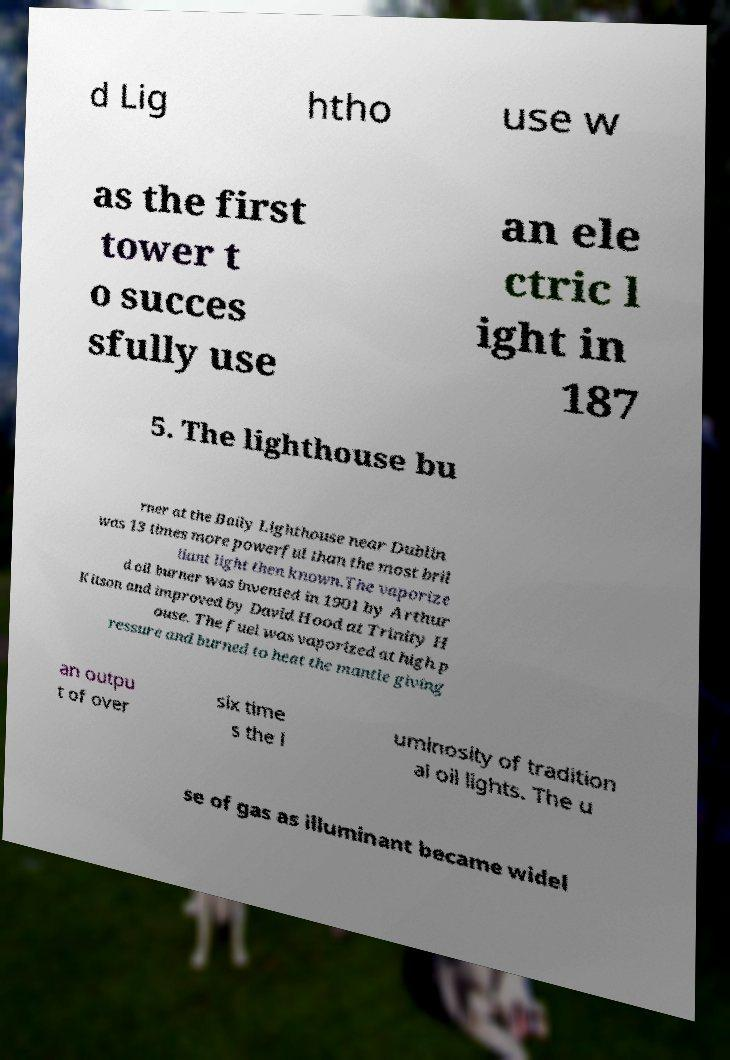I need the written content from this picture converted into text. Can you do that? d Lig htho use w as the first tower t o succes sfully use an ele ctric l ight in 187 5. The lighthouse bu rner at the Baily Lighthouse near Dublin was 13 times more powerful than the most bril liant light then known.The vaporize d oil burner was invented in 1901 by Arthur Kitson and improved by David Hood at Trinity H ouse. The fuel was vaporized at high p ressure and burned to heat the mantle giving an outpu t of over six time s the l uminosity of tradition al oil lights. The u se of gas as illuminant became widel 